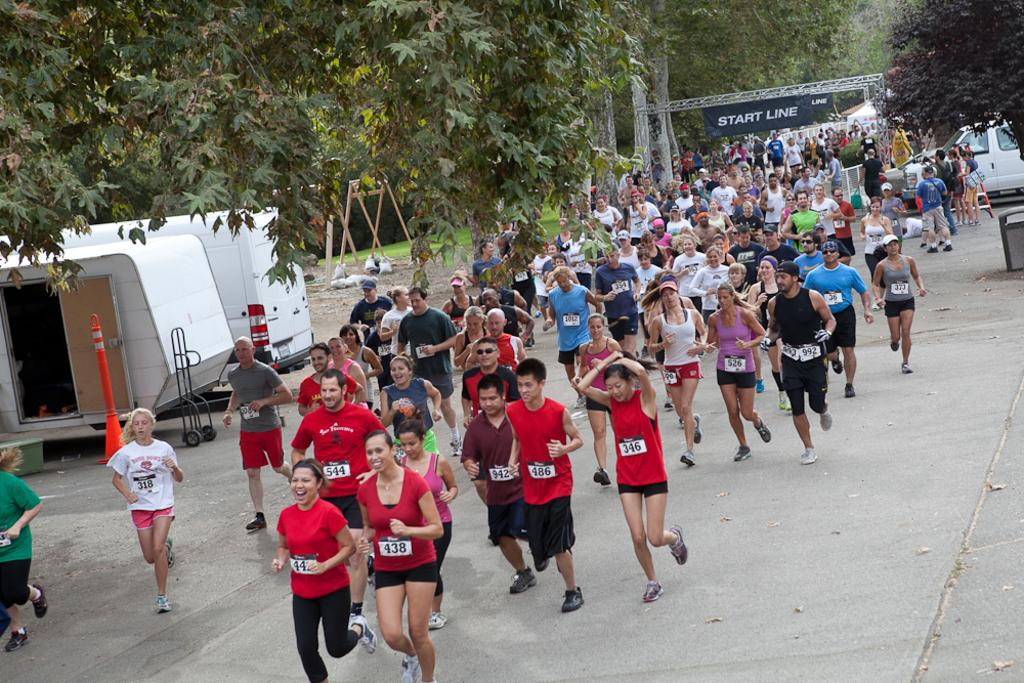What are the people in the image doing? The people in the crowd are running on the road. How can the runners be identified in the image? The people in the crowd are wearing chest numbers. What can be seen in the background of the image? There are trees visible in the image. What is on the left side of the road in the image? There are vehicles on the left side of the road. What is present in the background of the image? There is a banner in the background. How does the whistle affect the team's performance in the image? There is no whistle or team present in the image; it features a crowd of runners on the road. 